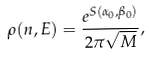<formula> <loc_0><loc_0><loc_500><loc_500>\rho ( n , E ) = \frac { e ^ { S ( \alpha _ { 0 } , \beta _ { 0 } ) } } { 2 \pi \sqrt { M } } ,</formula> 